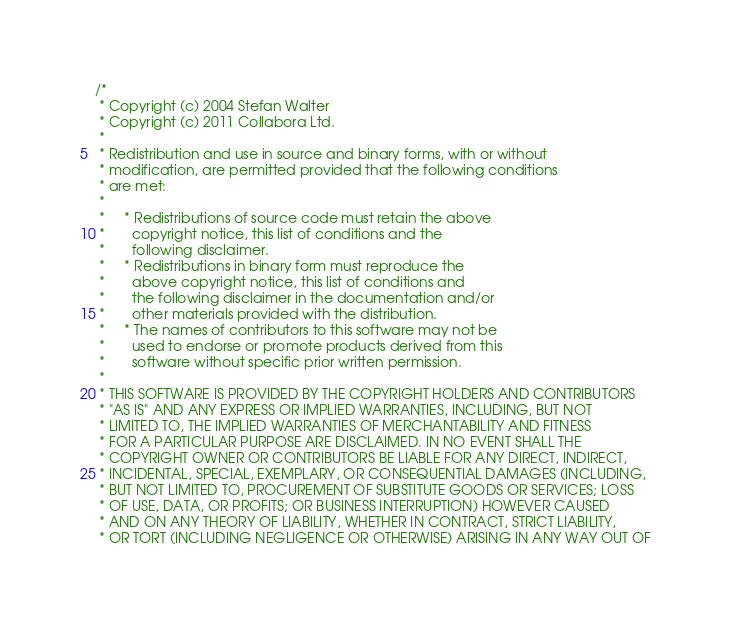Convert code to text. <code><loc_0><loc_0><loc_500><loc_500><_C_>/*
 * Copyright (c) 2004 Stefan Walter
 * Copyright (c) 2011 Collabora Ltd.
 *
 * Redistribution and use in source and binary forms, with or without
 * modification, are permitted provided that the following conditions
 * are met:
 *
 *     * Redistributions of source code must retain the above
 *       copyright notice, this list of conditions and the
 *       following disclaimer.
 *     * Redistributions in binary form must reproduce the
 *       above copyright notice, this list of conditions and
 *       the following disclaimer in the documentation and/or
 *       other materials provided with the distribution.
 *     * The names of contributors to this software may not be
 *       used to endorse or promote products derived from this
 *       software without specific prior written permission.
 *
 * THIS SOFTWARE IS PROVIDED BY THE COPYRIGHT HOLDERS AND CONTRIBUTORS
 * "AS IS" AND ANY EXPRESS OR IMPLIED WARRANTIES, INCLUDING, BUT NOT
 * LIMITED TO, THE IMPLIED WARRANTIES OF MERCHANTABILITY AND FITNESS
 * FOR A PARTICULAR PURPOSE ARE DISCLAIMED. IN NO EVENT SHALL THE
 * COPYRIGHT OWNER OR CONTRIBUTORS BE LIABLE FOR ANY DIRECT, INDIRECT,
 * INCIDENTAL, SPECIAL, EXEMPLARY, OR CONSEQUENTIAL DAMAGES (INCLUDING,
 * BUT NOT LIMITED TO, PROCUREMENT OF SUBSTITUTE GOODS OR SERVICES; LOSS
 * OF USE, DATA, OR PROFITS; OR BUSINESS INTERRUPTION) HOWEVER CAUSED
 * AND ON ANY THEORY OF LIABILITY, WHETHER IN CONTRACT, STRICT LIABILITY,
 * OR TORT (INCLUDING NEGLIGENCE OR OTHERWISE) ARISING IN ANY WAY OUT OF</code> 